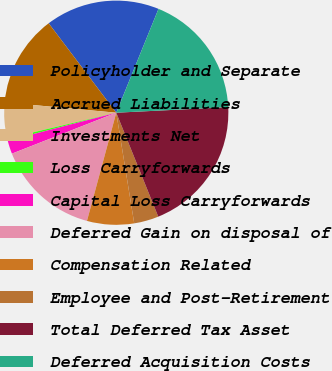Convert chart to OTSL. <chart><loc_0><loc_0><loc_500><loc_500><pie_chart><fcel>Policyholder and Separate<fcel>Accrued Liabilities<fcel>Investments Net<fcel>Loss Carryforwards<fcel>Capital Loss Carryforwards<fcel>Deferred Gain on disposal of<fcel>Compensation Related<fcel>Employee and Post-Retirement<fcel>Total Deferred Tax Asset<fcel>Deferred Acquisition Costs<nl><fcel>16.45%<fcel>13.23%<fcel>5.16%<fcel>0.32%<fcel>1.94%<fcel>14.84%<fcel>6.77%<fcel>3.55%<fcel>19.68%<fcel>18.06%<nl></chart> 